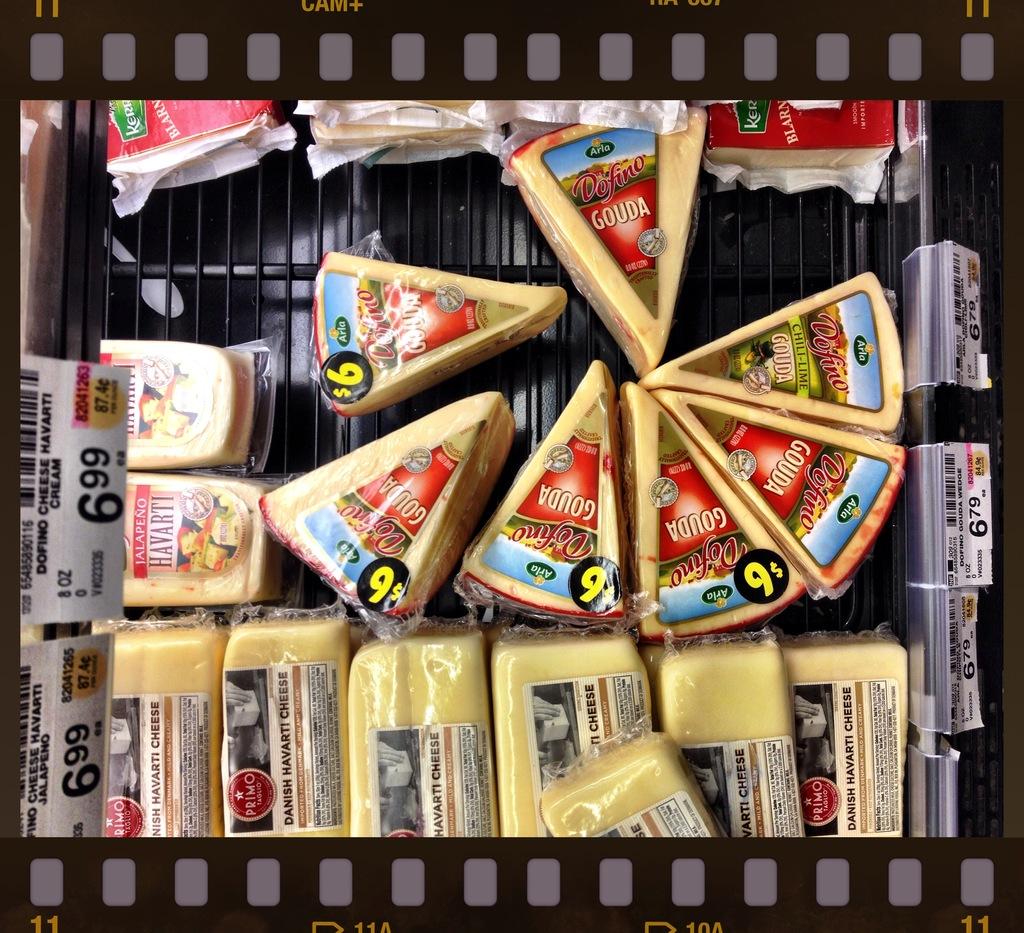How much is the slice of gouda?
Offer a very short reply. 9. What brand of cheese are these?
Make the answer very short. Gouda. 